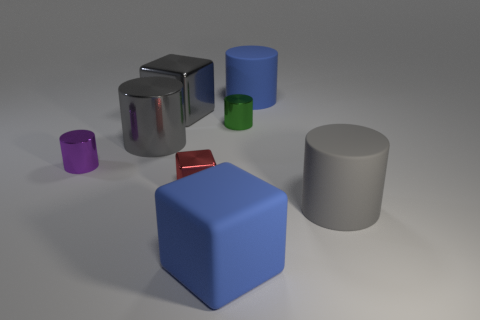Subtract all large gray cylinders. How many cylinders are left? 3 Subtract all gray cylinders. How many cylinders are left? 3 Subtract all cylinders. How many objects are left? 3 Subtract 1 blocks. How many blocks are left? 2 Subtract all brown blocks. Subtract all cyan spheres. How many blocks are left? 3 Subtract all gray cubes. How many green cylinders are left? 1 Subtract all blue metal objects. Subtract all metallic cylinders. How many objects are left? 5 Add 4 gray cylinders. How many gray cylinders are left? 6 Add 4 large cyan matte cylinders. How many large cyan matte cylinders exist? 4 Add 1 large yellow metal cylinders. How many objects exist? 9 